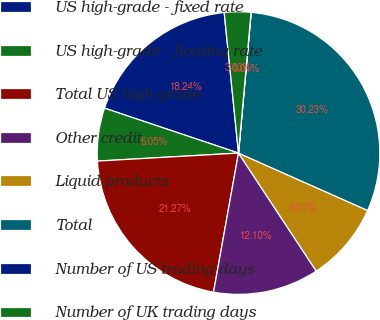Convert chart. <chart><loc_0><loc_0><loc_500><loc_500><pie_chart><fcel>US high-grade - fixed rate<fcel>US high-grade - floating rate<fcel>Total US high-grade<fcel>Other credit<fcel>Liquid products<fcel>Total<fcel>Number of US trading days<fcel>Number of UK trading days<nl><fcel>18.24%<fcel>6.05%<fcel>21.27%<fcel>12.1%<fcel>9.07%<fcel>30.23%<fcel>0.01%<fcel>3.03%<nl></chart> 